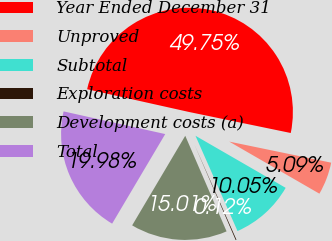<chart> <loc_0><loc_0><loc_500><loc_500><pie_chart><fcel>Year Ended December 31<fcel>Unproved<fcel>Subtotal<fcel>Exploration costs<fcel>Development costs (a)<fcel>Total<nl><fcel>49.75%<fcel>5.09%<fcel>10.05%<fcel>0.12%<fcel>15.01%<fcel>19.98%<nl></chart> 